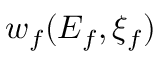Convert formula to latex. <formula><loc_0><loc_0><loc_500><loc_500>w _ { f } ( E _ { f } , \xi _ { f } )</formula> 